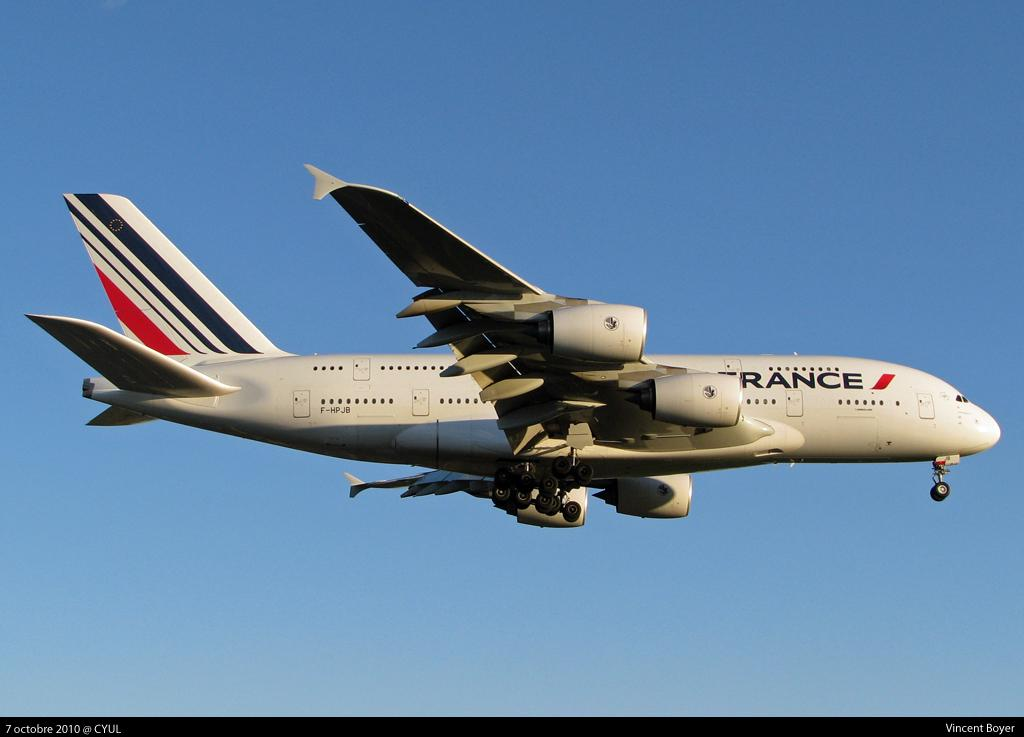<image>
Create a compact narrative representing the image presented. A french plane flying in the sky, it looks like it is intact and flying smoothly. 